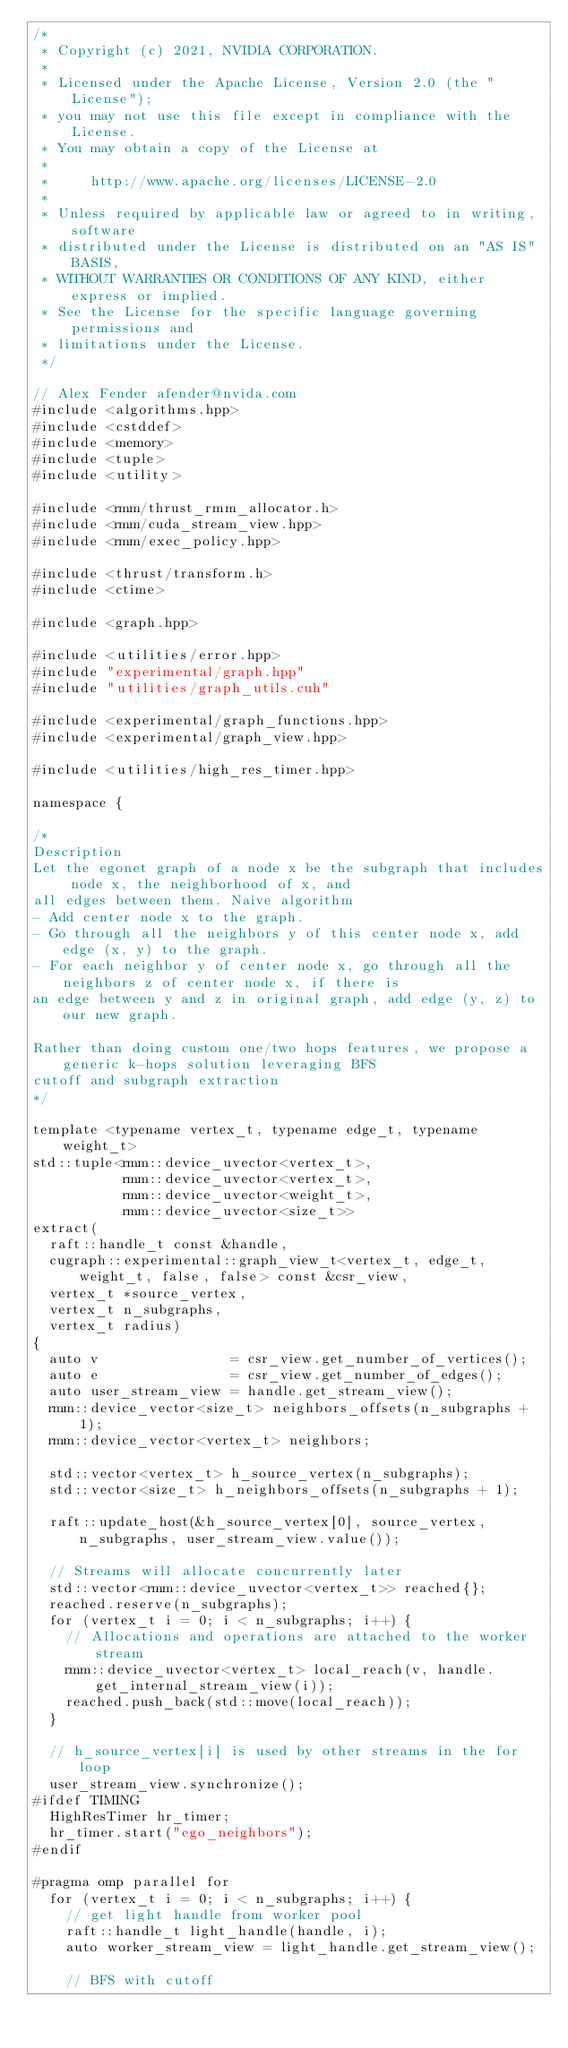Convert code to text. <code><loc_0><loc_0><loc_500><loc_500><_Cuda_>/*
 * Copyright (c) 2021, NVIDIA CORPORATION.
 *
 * Licensed under the Apache License, Version 2.0 (the "License");
 * you may not use this file except in compliance with the License.
 * You may obtain a copy of the License at
 *
 *     http://www.apache.org/licenses/LICENSE-2.0
 *
 * Unless required by applicable law or agreed to in writing, software
 * distributed under the License is distributed on an "AS IS" BASIS,
 * WITHOUT WARRANTIES OR CONDITIONS OF ANY KIND, either express or implied.
 * See the License for the specific language governing permissions and
 * limitations under the License.
 */

// Alex Fender afender@nvida.com
#include <algorithms.hpp>
#include <cstddef>
#include <memory>
#include <tuple>
#include <utility>

#include <rmm/thrust_rmm_allocator.h>
#include <rmm/cuda_stream_view.hpp>
#include <rmm/exec_policy.hpp>

#include <thrust/transform.h>
#include <ctime>

#include <graph.hpp>

#include <utilities/error.hpp>
#include "experimental/graph.hpp"
#include "utilities/graph_utils.cuh"

#include <experimental/graph_functions.hpp>
#include <experimental/graph_view.hpp>

#include <utilities/high_res_timer.hpp>

namespace {

/*
Description
Let the egonet graph of a node x be the subgraph that includes node x, the neighborhood of x, and
all edges between them. Naive algorithm
- Add center node x to the graph.
- Go through all the neighbors y of this center node x, add edge (x, y) to the graph.
- For each neighbor y of center node x, go through all the neighbors z of center node x, if there is
an edge between y and z in original graph, add edge (y, z) to our new graph.

Rather than doing custom one/two hops features, we propose a generic k-hops solution leveraging BFS
cutoff and subgraph extraction
*/

template <typename vertex_t, typename edge_t, typename weight_t>
std::tuple<rmm::device_uvector<vertex_t>,
           rmm::device_uvector<vertex_t>,
           rmm::device_uvector<weight_t>,
           rmm::device_uvector<size_t>>
extract(
  raft::handle_t const &handle,
  cugraph::experimental::graph_view_t<vertex_t, edge_t, weight_t, false, false> const &csr_view,
  vertex_t *source_vertex,
  vertex_t n_subgraphs,
  vertex_t radius)
{
  auto v                = csr_view.get_number_of_vertices();
  auto e                = csr_view.get_number_of_edges();
  auto user_stream_view = handle.get_stream_view();
  rmm::device_vector<size_t> neighbors_offsets(n_subgraphs + 1);
  rmm::device_vector<vertex_t> neighbors;

  std::vector<vertex_t> h_source_vertex(n_subgraphs);
  std::vector<size_t> h_neighbors_offsets(n_subgraphs + 1);

  raft::update_host(&h_source_vertex[0], source_vertex, n_subgraphs, user_stream_view.value());

  // Streams will allocate concurrently later
  std::vector<rmm::device_uvector<vertex_t>> reached{};
  reached.reserve(n_subgraphs);
  for (vertex_t i = 0; i < n_subgraphs; i++) {
    // Allocations and operations are attached to the worker stream
    rmm::device_uvector<vertex_t> local_reach(v, handle.get_internal_stream_view(i));
    reached.push_back(std::move(local_reach));
  }

  // h_source_vertex[i] is used by other streams in the for loop
  user_stream_view.synchronize();
#ifdef TIMING
  HighResTimer hr_timer;
  hr_timer.start("ego_neighbors");
#endif

#pragma omp parallel for
  for (vertex_t i = 0; i < n_subgraphs; i++) {
    // get light handle from worker pool
    raft::handle_t light_handle(handle, i);
    auto worker_stream_view = light_handle.get_stream_view();

    // BFS with cutoff</code> 